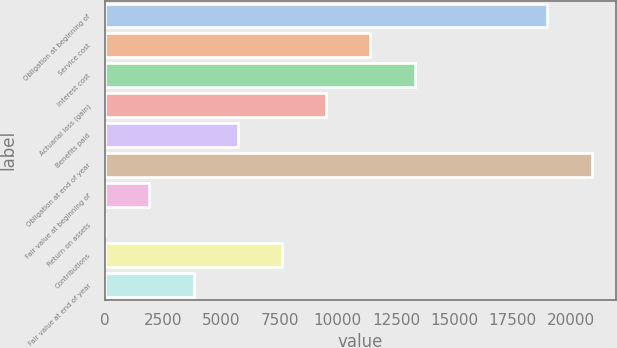Convert chart to OTSL. <chart><loc_0><loc_0><loc_500><loc_500><bar_chart><fcel>Obligation at beginning of<fcel>Service cost<fcel>Interest cost<fcel>Actuarial loss (gain)<fcel>Benefits paid<fcel>Obligation at end of year<fcel>Fair value at beginning of<fcel>Return on assets<fcel>Contributions<fcel>Fair value at end of year<nl><fcel>19008<fcel>11405.4<fcel>13306.1<fcel>9504.81<fcel>5703.55<fcel>20908.6<fcel>1902.29<fcel>1.66<fcel>7604.18<fcel>3802.92<nl></chart> 